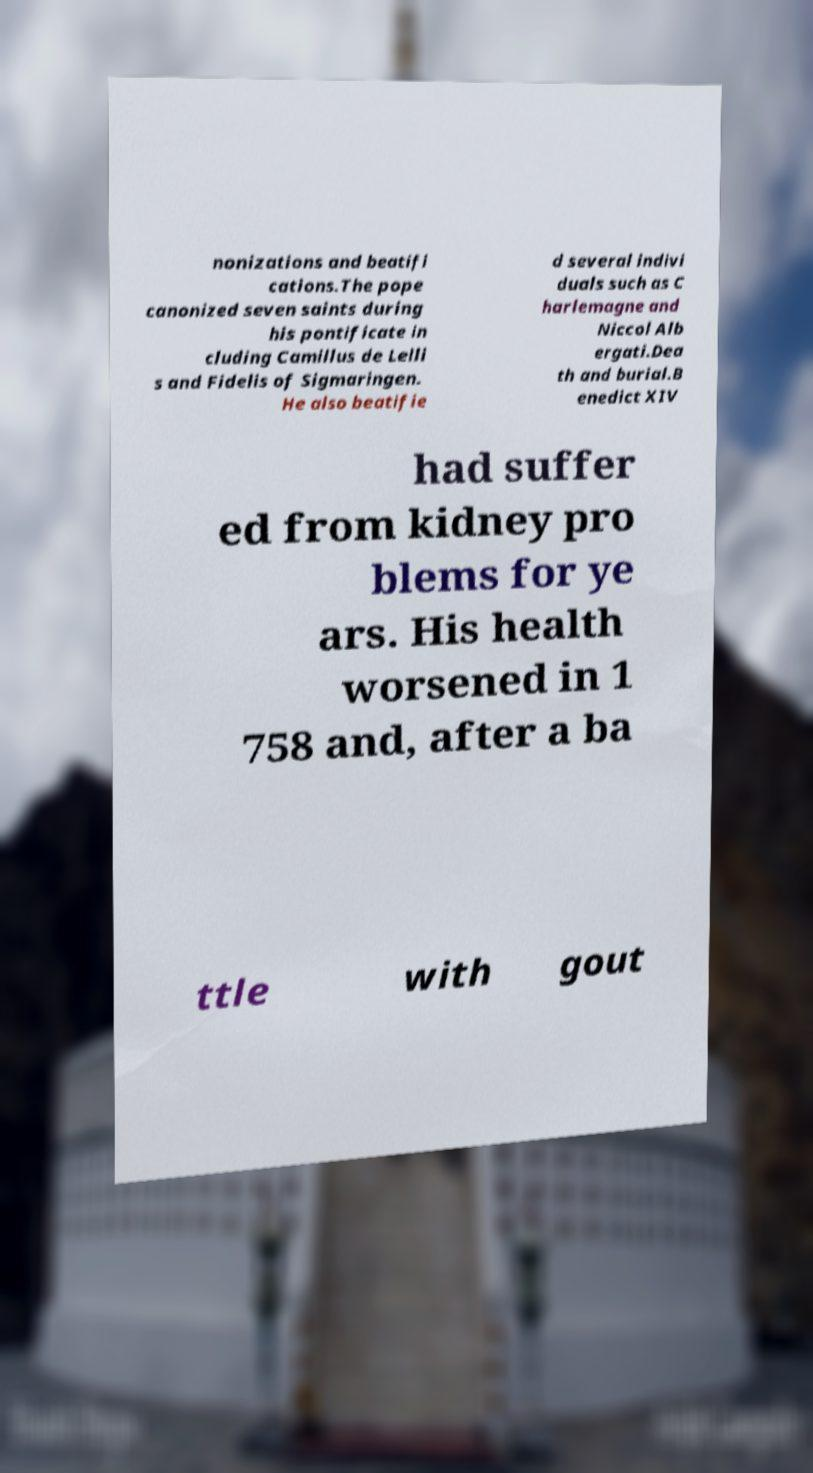What messages or text are displayed in this image? I need them in a readable, typed format. nonizations and beatifi cations.The pope canonized seven saints during his pontificate in cluding Camillus de Lelli s and Fidelis of Sigmaringen. He also beatifie d several indivi duals such as C harlemagne and Niccol Alb ergati.Dea th and burial.B enedict XIV had suffer ed from kidney pro blems for ye ars. His health worsened in 1 758 and, after a ba ttle with gout 